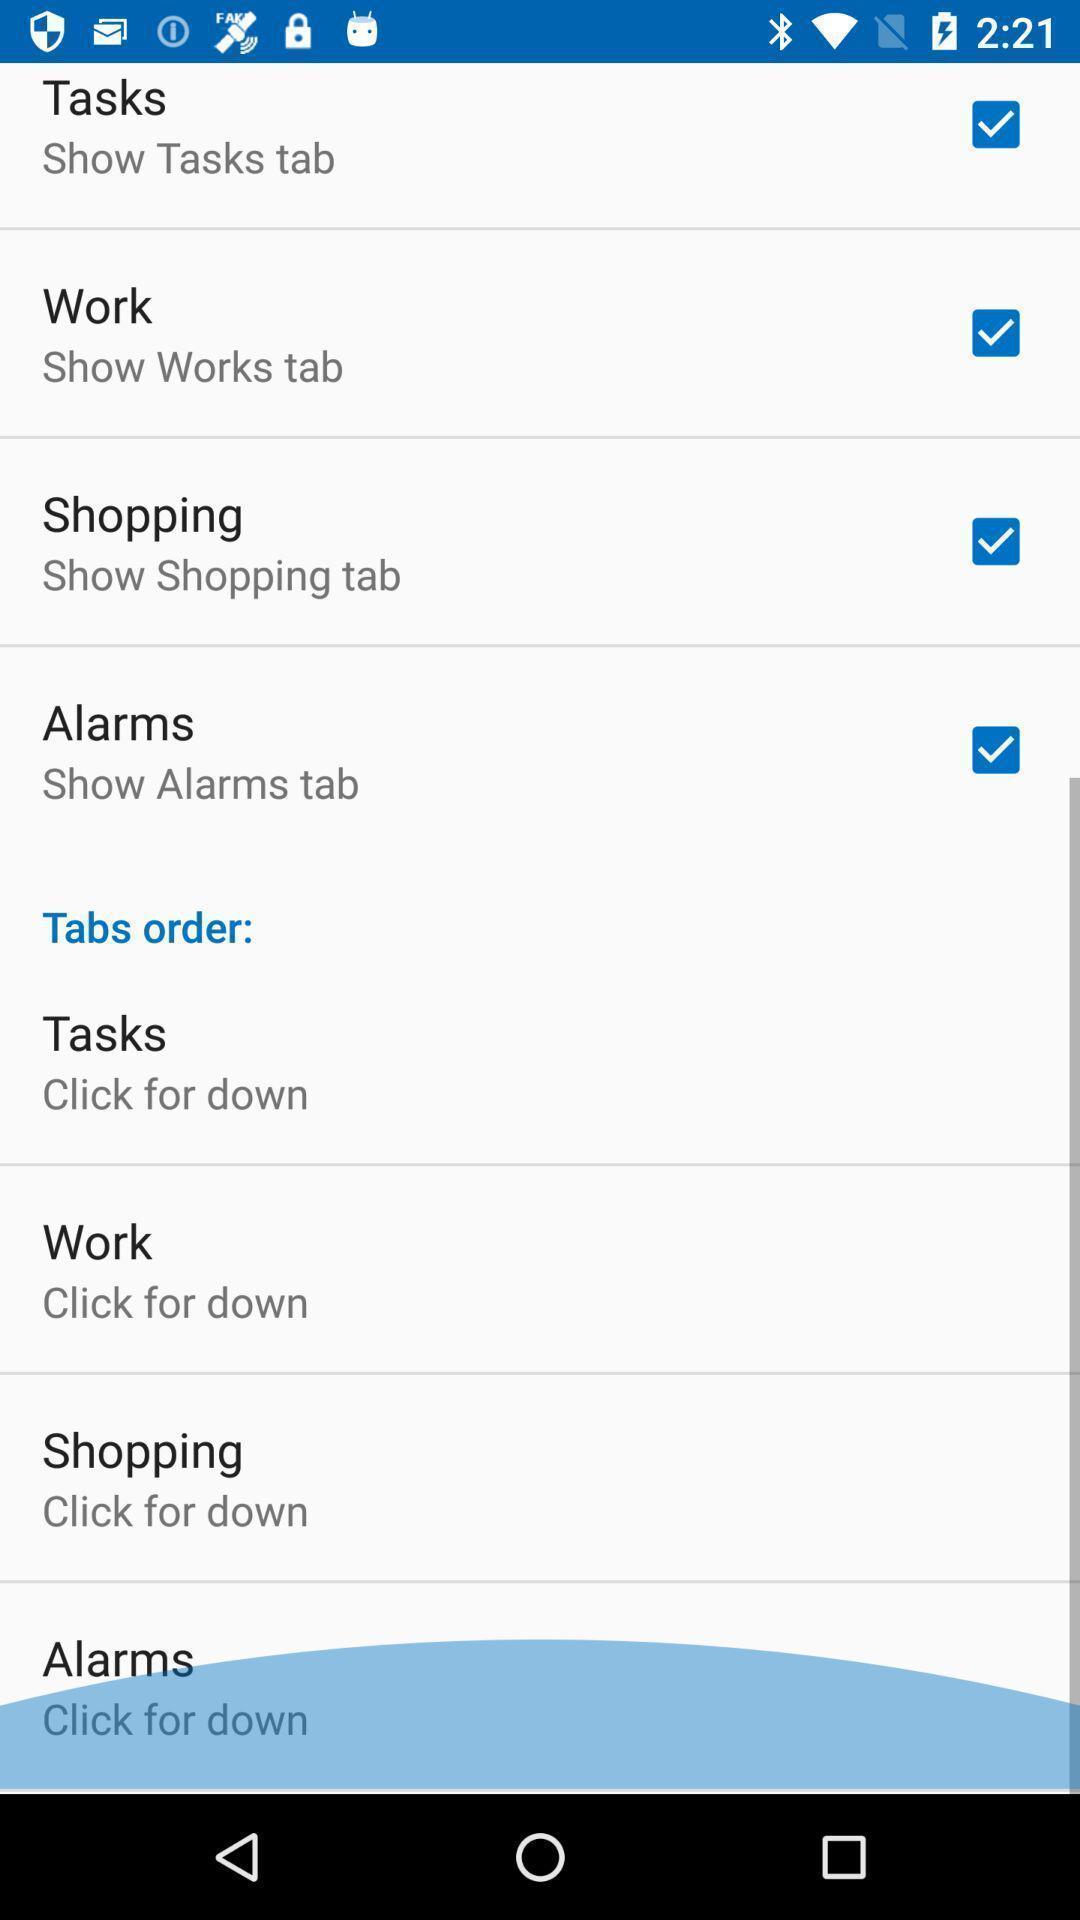Give me a narrative description of this picture. Page showing tabs setting options. 